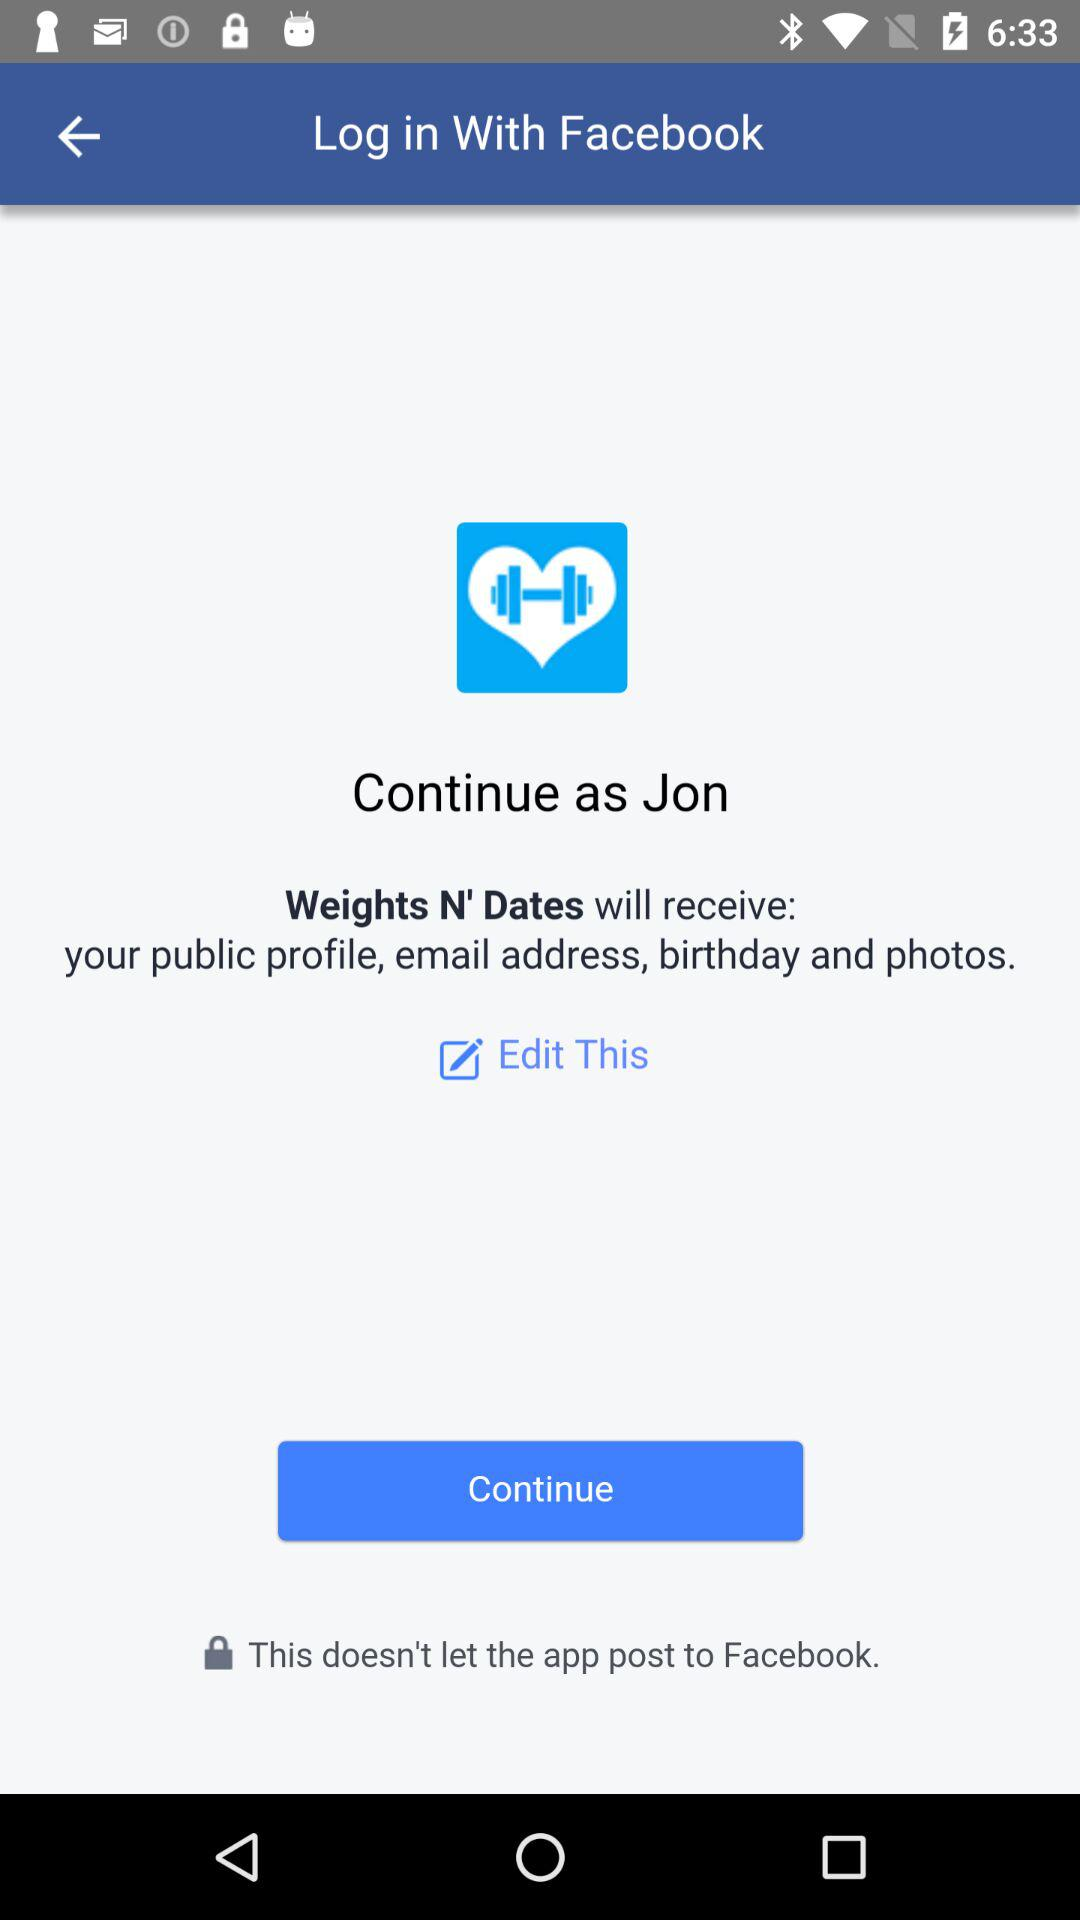What is the name of the user? The user name is Jon. 